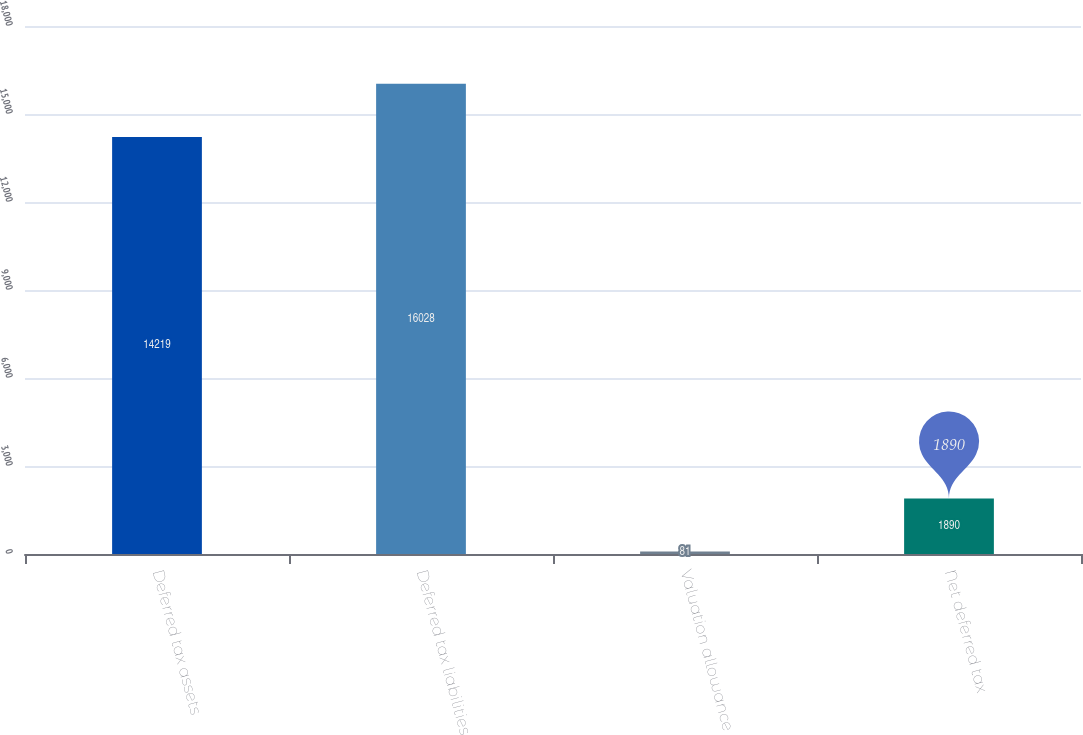Convert chart to OTSL. <chart><loc_0><loc_0><loc_500><loc_500><bar_chart><fcel>Deferred tax assets<fcel>Deferred tax liabilities<fcel>Valuation allowance<fcel>Net deferred tax<nl><fcel>14219<fcel>16028<fcel>81<fcel>1890<nl></chart> 